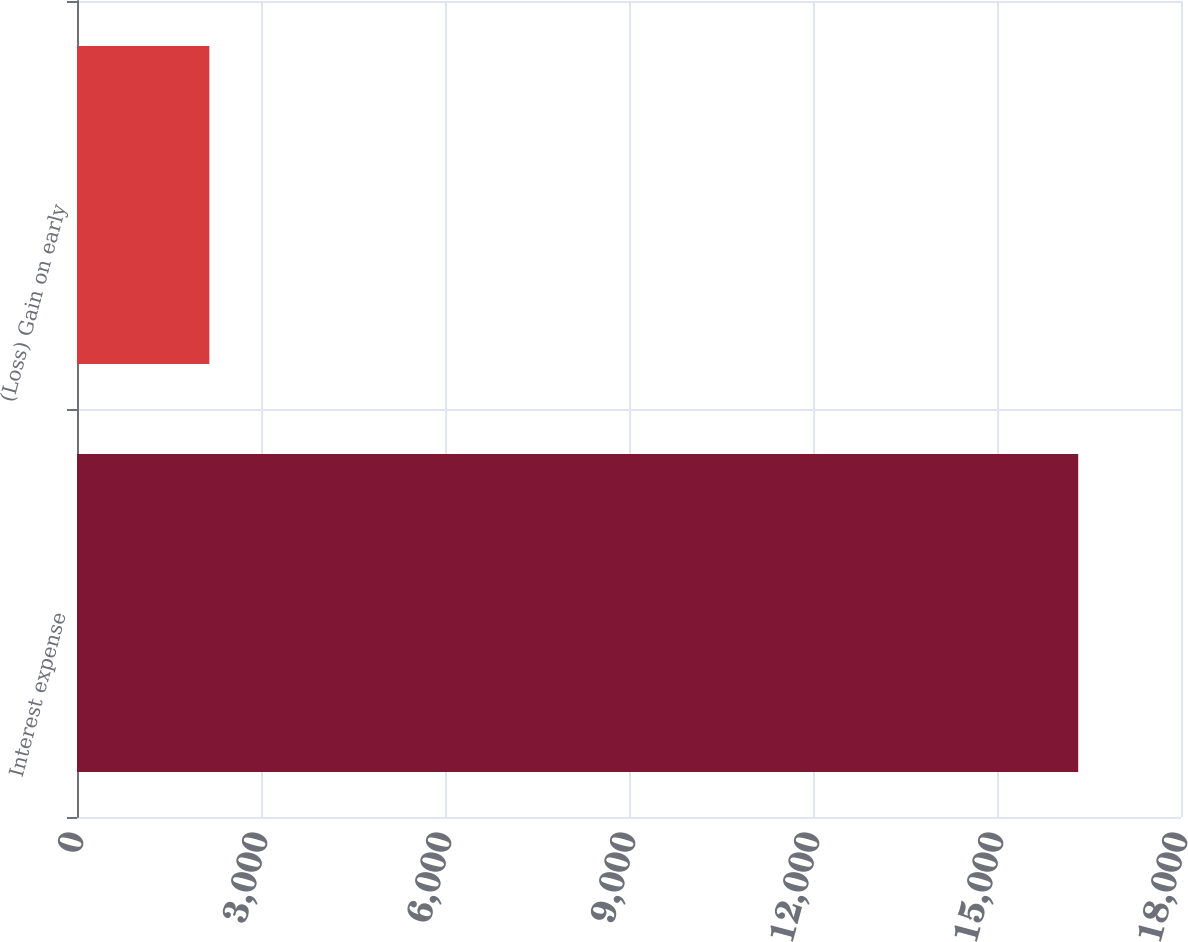<chart> <loc_0><loc_0><loc_500><loc_500><bar_chart><fcel>Interest expense<fcel>(Loss) Gain on early<nl><fcel>16324<fcel>2158<nl></chart> 